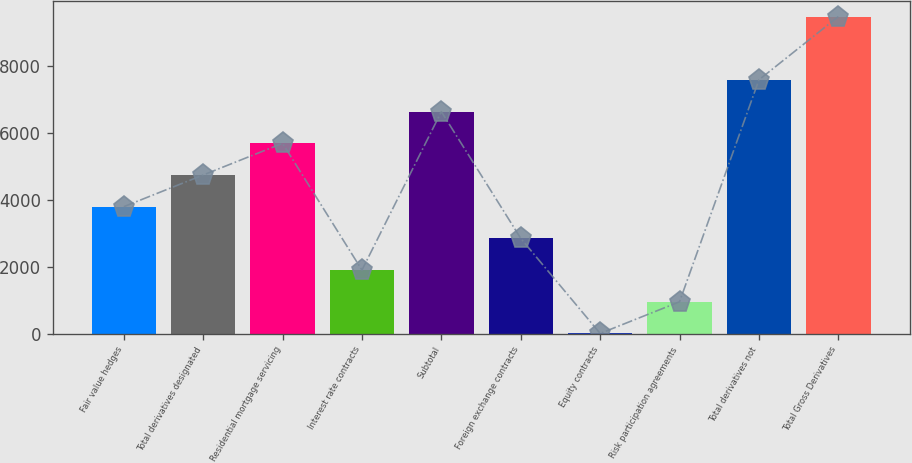Convert chart to OTSL. <chart><loc_0><loc_0><loc_500><loc_500><bar_chart><fcel>Fair value hedges<fcel>Total derivatives designated<fcel>Residential mortgage servicing<fcel>Interest rate contracts<fcel>Subtotal<fcel>Foreign exchange contracts<fcel>Equity contracts<fcel>Risk participation agreements<fcel>Total derivatives not<fcel>Total Gross Derivatives<nl><fcel>3788.2<fcel>4734<fcel>5679.8<fcel>1896.6<fcel>6625.6<fcel>2842.4<fcel>5<fcel>950.8<fcel>7575<fcel>9463<nl></chart> 